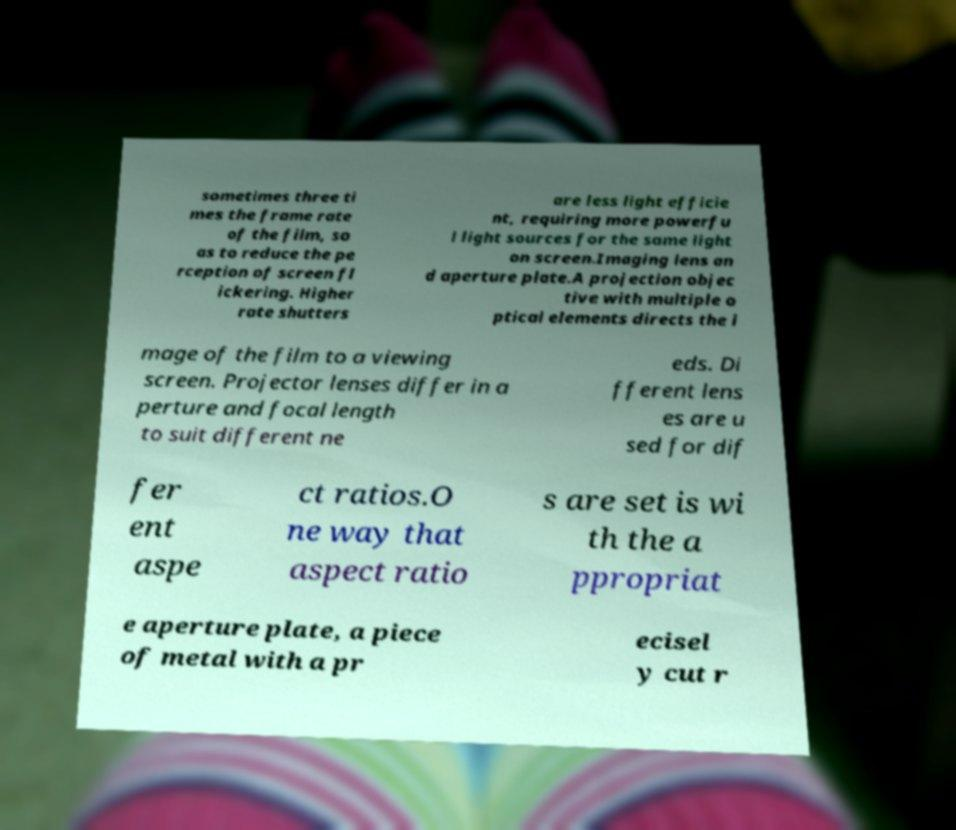For documentation purposes, I need the text within this image transcribed. Could you provide that? sometimes three ti mes the frame rate of the film, so as to reduce the pe rception of screen fl ickering. Higher rate shutters are less light efficie nt, requiring more powerfu l light sources for the same light on screen.Imaging lens an d aperture plate.A projection objec tive with multiple o ptical elements directs the i mage of the film to a viewing screen. Projector lenses differ in a perture and focal length to suit different ne eds. Di fferent lens es are u sed for dif fer ent aspe ct ratios.O ne way that aspect ratio s are set is wi th the a ppropriat e aperture plate, a piece of metal with a pr ecisel y cut r 